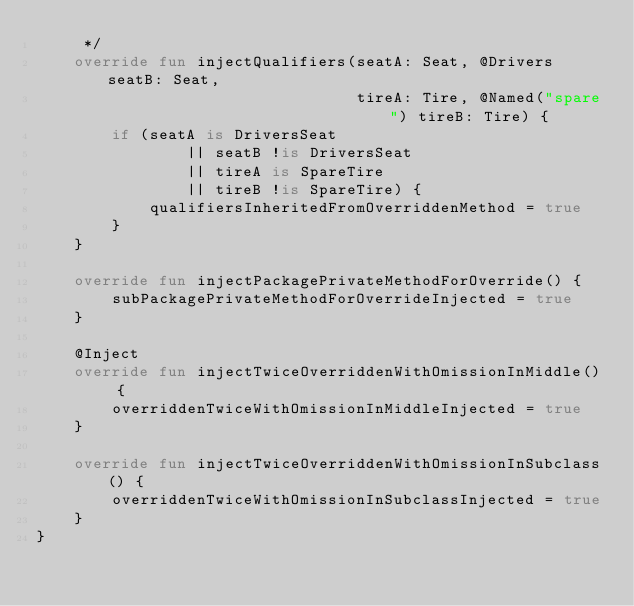Convert code to text. <code><loc_0><loc_0><loc_500><loc_500><_Kotlin_>     */
    override fun injectQualifiers(seatA: Seat, @Drivers seatB: Seat,
                                  tireA: Tire, @Named("spare") tireB: Tire) {
        if (seatA is DriversSeat
                || seatB !is DriversSeat
                || tireA is SpareTire
                || tireB !is SpareTire) {
            qualifiersInheritedFromOverriddenMethod = true
        }
    }

    override fun injectPackagePrivateMethodForOverride() {
        subPackagePrivateMethodForOverrideInjected = true
    }

    @Inject
    override fun injectTwiceOverriddenWithOmissionInMiddle() {
        overriddenTwiceWithOmissionInMiddleInjected = true
    }

    override fun injectTwiceOverriddenWithOmissionInSubclass() {
        overriddenTwiceWithOmissionInSubclassInjected = true
    }
}
</code> 